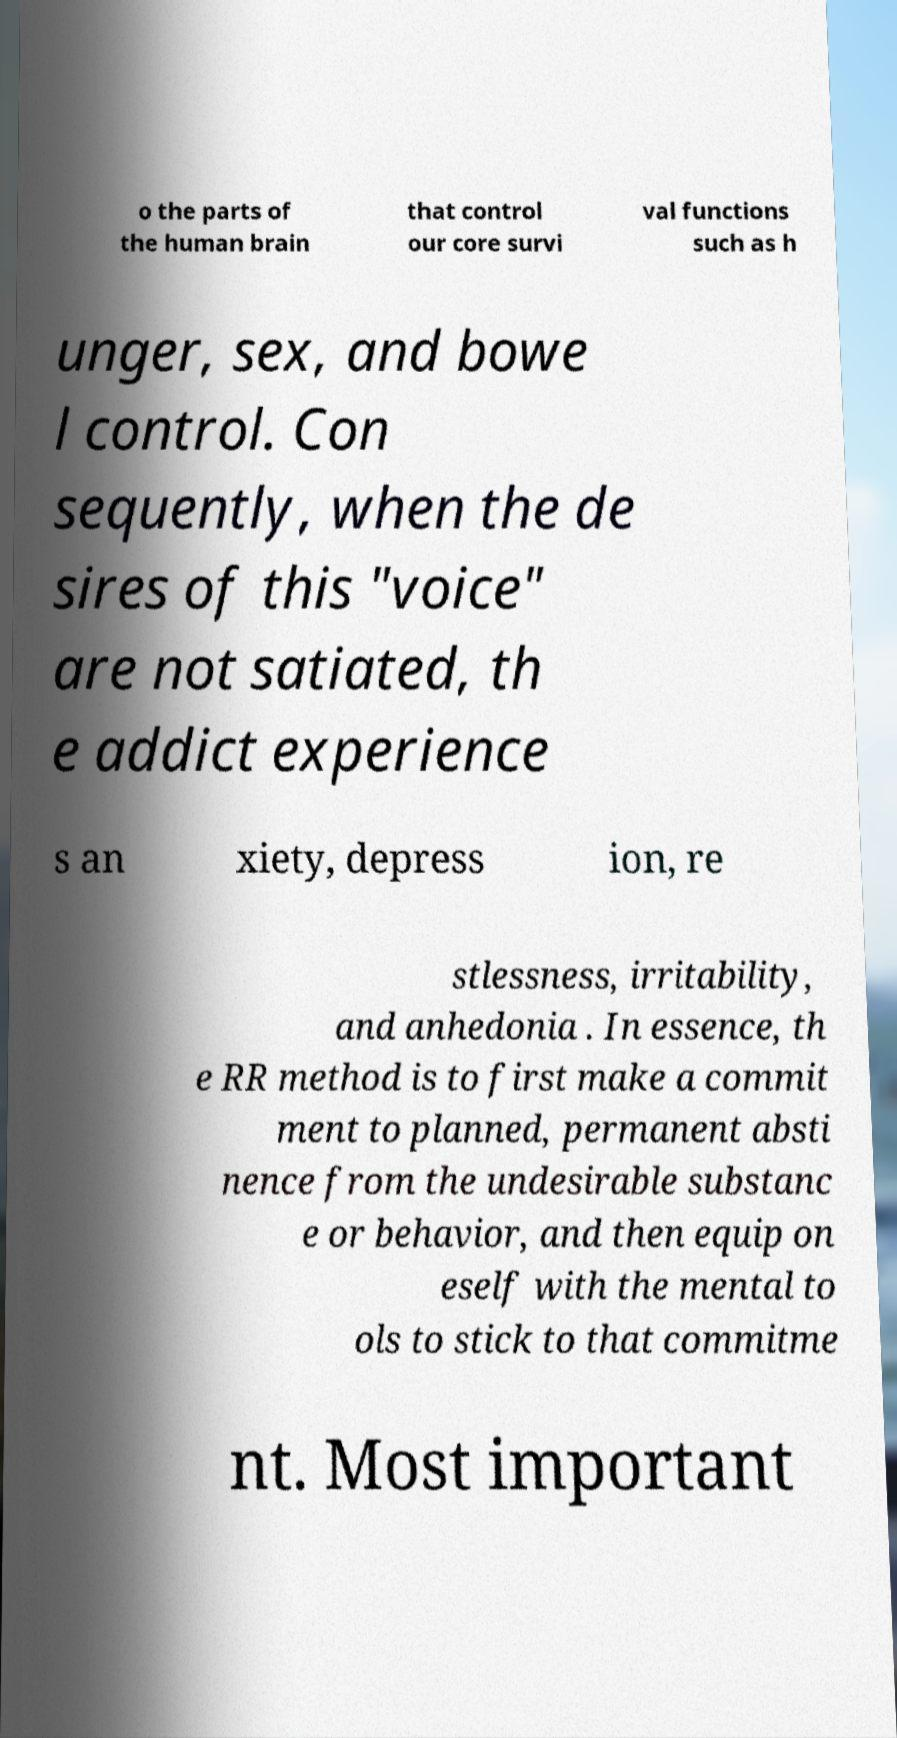What messages or text are displayed in this image? I need them in a readable, typed format. o the parts of the human brain that control our core survi val functions such as h unger, sex, and bowe l control. Con sequently, when the de sires of this "voice" are not satiated, th e addict experience s an xiety, depress ion, re stlessness, irritability, and anhedonia . In essence, th e RR method is to first make a commit ment to planned, permanent absti nence from the undesirable substanc e or behavior, and then equip on eself with the mental to ols to stick to that commitme nt. Most important 